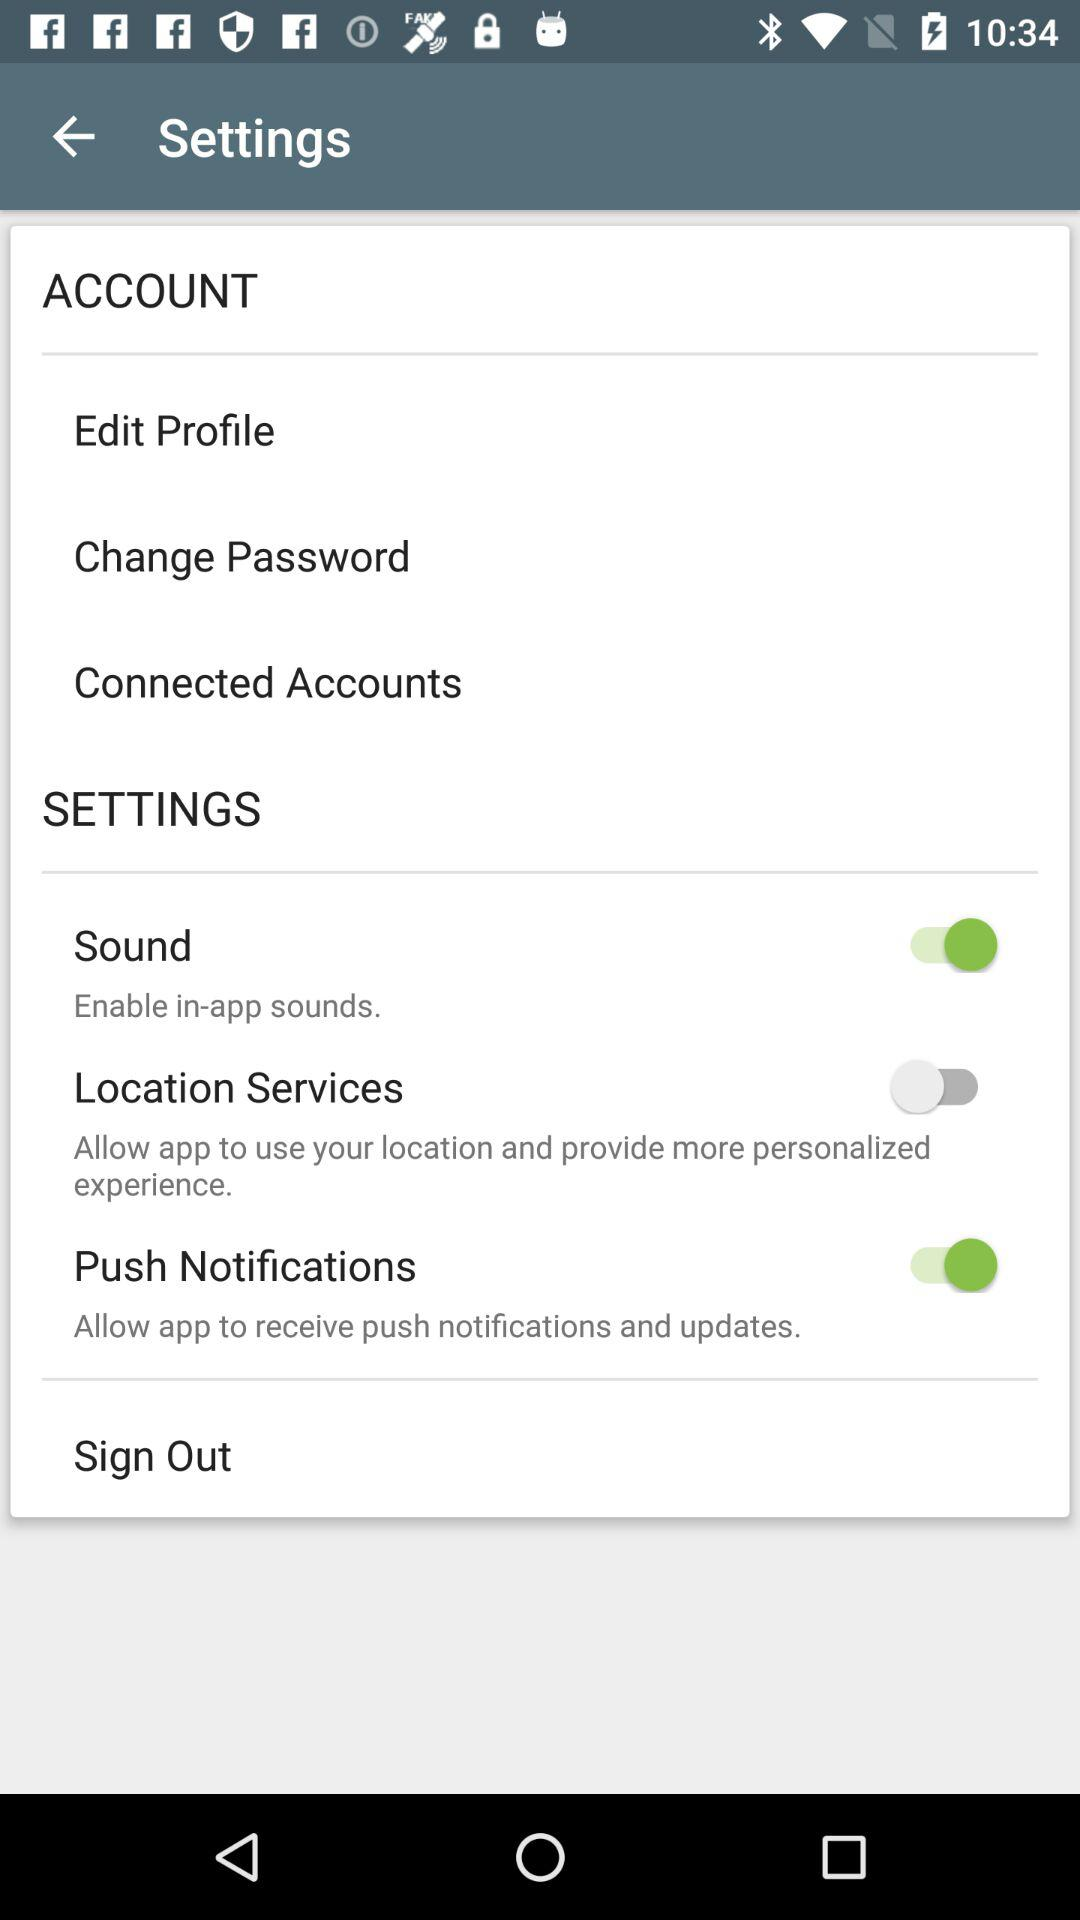What is the status of the location services? The status of the location services is off. 